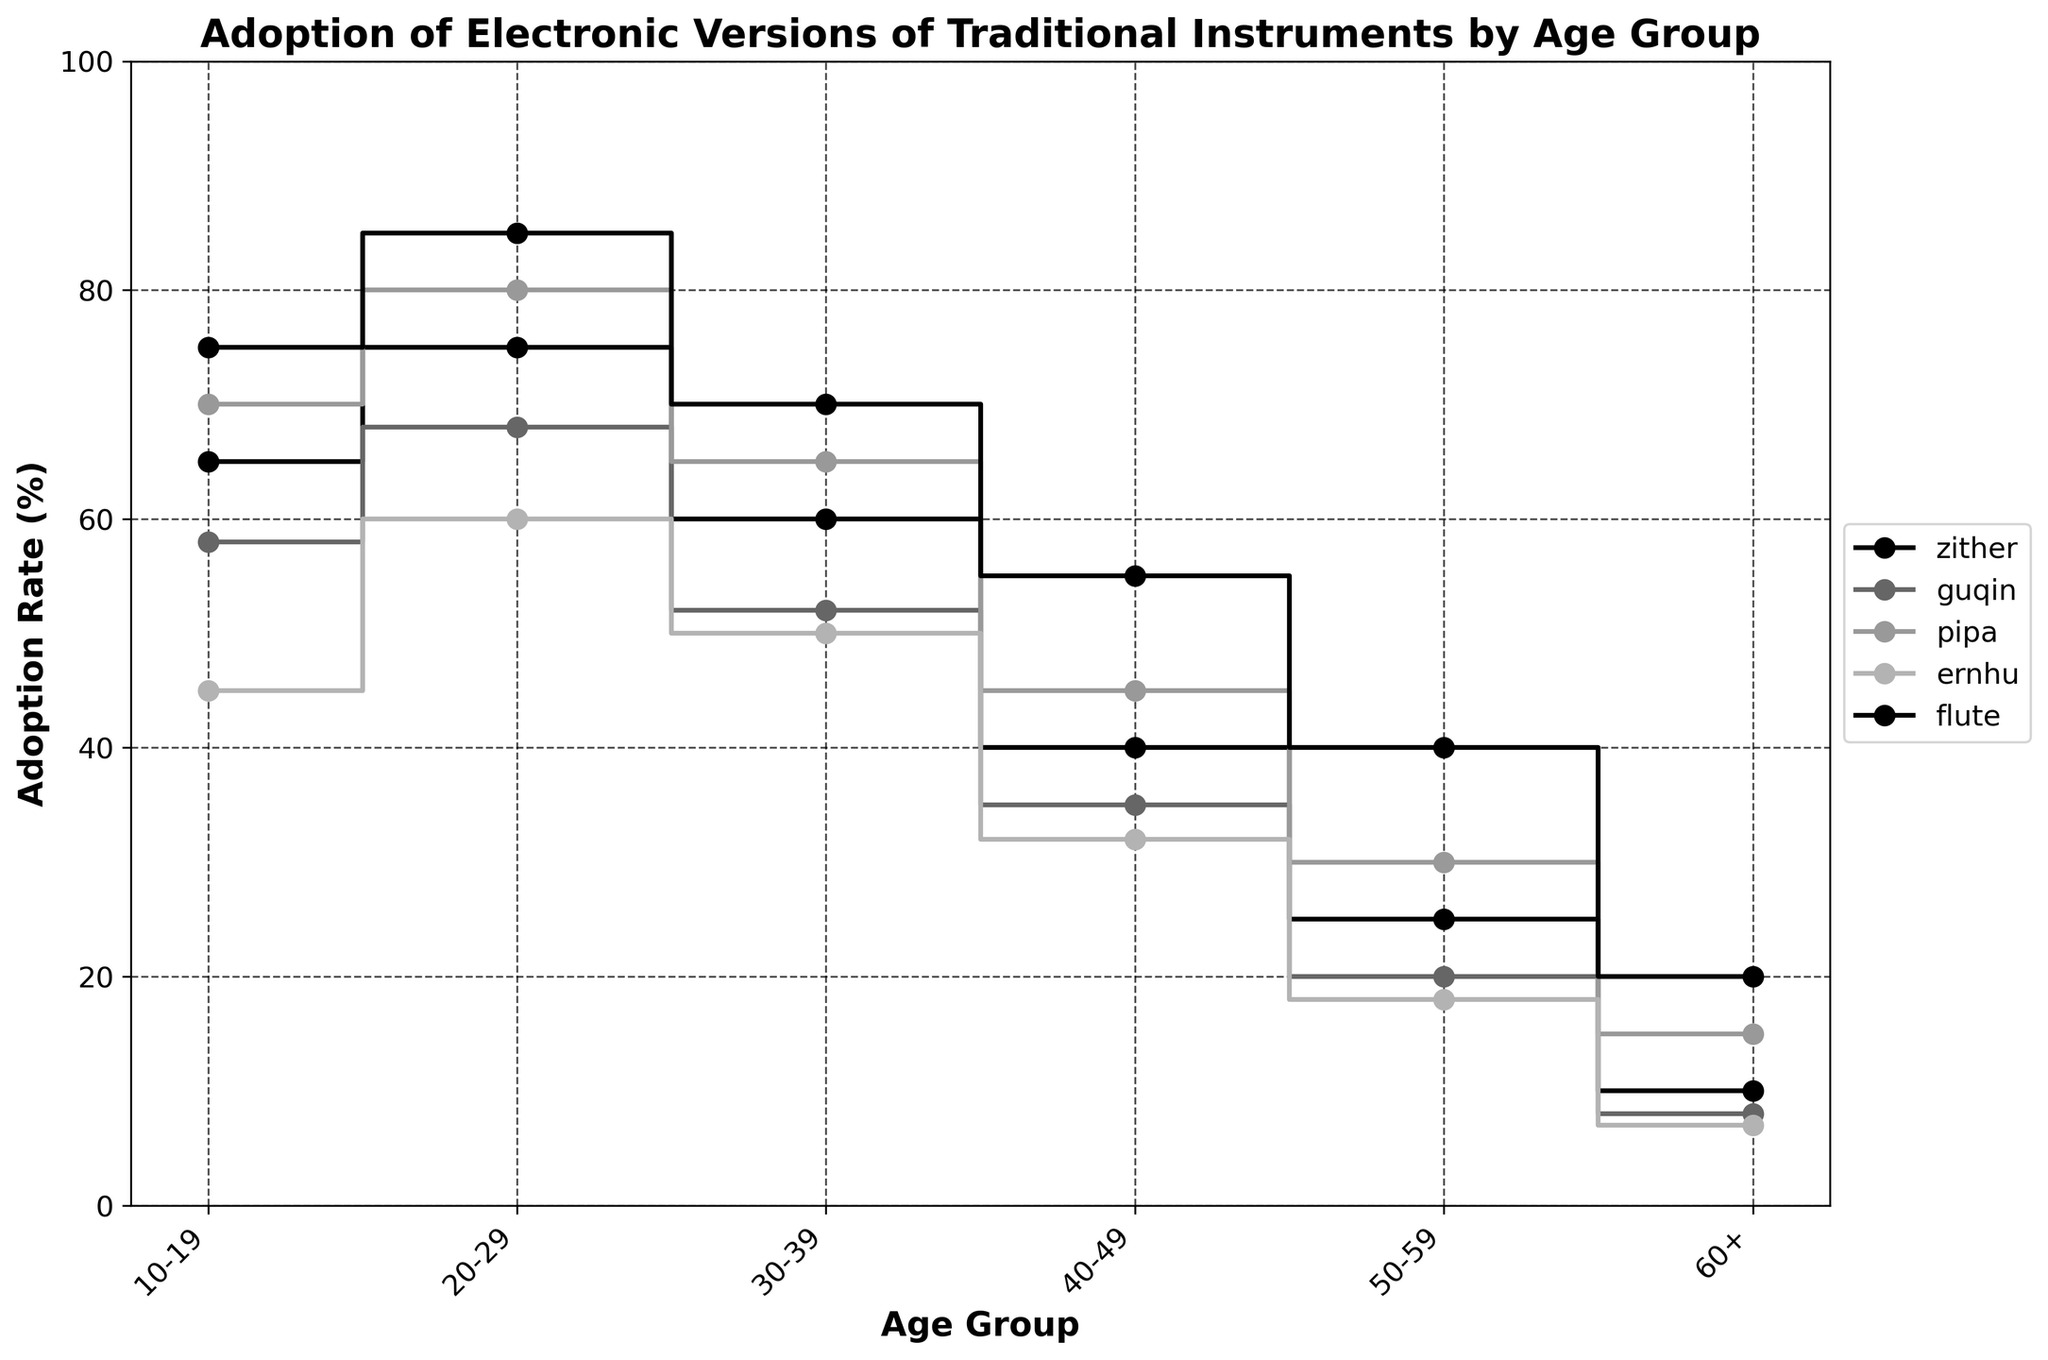What is the title of the plot? The title of the plot is written at the top of the figure, indicating the main subject of the chart.
Answer: Adoption of Electronic Versions of Traditional Instruments by Age Group Which instrument has the highest adoption rate among the 20-29 age group? To find the answer, look for the values associated with the 20-29 age group and identify the highest percentage.
Answer: Electronic Flute How does the adoption rate of the electronic erhu change from the 10-19 age group to the 60+ age group? Compare the values for the electronic erhu in these two age groups. The adoption rate decreases from 45% in the 10-19 age group to 7% in the 60+ age group.
Answer: It decreases Which age group has the least adoption of the electronic guqin? To find the answer, identify the smallest value in the series for the electronic guqin across all age groups.
Answer: 60+ Which two instruments have the closest adoption rates in the 30-39 age group? Look at the percentages for each instrument in the 30-39 age group and find the two instruments with the smallest difference in their adoption rates.
Answer: Electronic Pipa & Electronic Flute What's the average adoption rate of the electronic pipa across all age groups? Sum the adoption rates of the electronic pipa for each age group and divide by the number of age groups (6). The calculation is (70 + 80 + 65 + 45 + 30 + 15) / 6 = 305 / 6 ≈ 50.83.
Answer: Approximately 50.83 Which instrument shows the most significant decrease in adoption rate from the 20-29 age group to the 40-49 age group? Calculate the difference in adoption rates for each instrument between these two age groups. The electronic flute decreases the most by 85 - 55 = 30%.
Answer: Electronic Flute How does the adoption rate of the electronic zither in the 50-59 age group compare to the 10-19 age group? Compare the adoption rates for the electronic zither in the 50-59 age group (25%) and the 10-19 age group (65%). It shows a decrease by 65 - 25 = 40%.
Answer: It is 40% lower What pattern do you observe in the adoption rates of electronic instruments as the age groups increase? Observe the general trend in adoption rates across instruments as the age group moves from 10-19 to 60+. The adoption rates tend to decrease as age groups increase.
Answer: Decreasing trend Which age group has the highest overall adoption rate among all electronic instruments? Sum the adoption rates for all instruments within each age group and determine which age group has the highest total number. The 20-29 age group has the highest: 75 + 68 + 80 + 60 + 85 = 368.
Answer: 20-29 